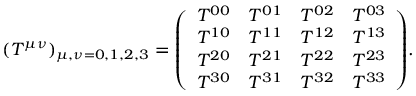Convert formula to latex. <formula><loc_0><loc_0><loc_500><loc_500>( T ^ { \mu \nu } ) _ { \mu , \nu = 0 , 1 , 2 , 3 } = { \left ( \begin{array} { l l l l } { T ^ { 0 0 } } & { T ^ { 0 1 } } & { T ^ { 0 2 } } & { T ^ { 0 3 } } \\ { T ^ { 1 0 } } & { T ^ { 1 1 } } & { T ^ { 1 2 } } & { T ^ { 1 3 } } \\ { T ^ { 2 0 } } & { T ^ { 2 1 } } & { T ^ { 2 2 } } & { T ^ { 2 3 } } \\ { T ^ { 3 0 } } & { T ^ { 3 1 } } & { T ^ { 3 2 } } & { T ^ { 3 3 } } \end{array} \right ) } .</formula> 